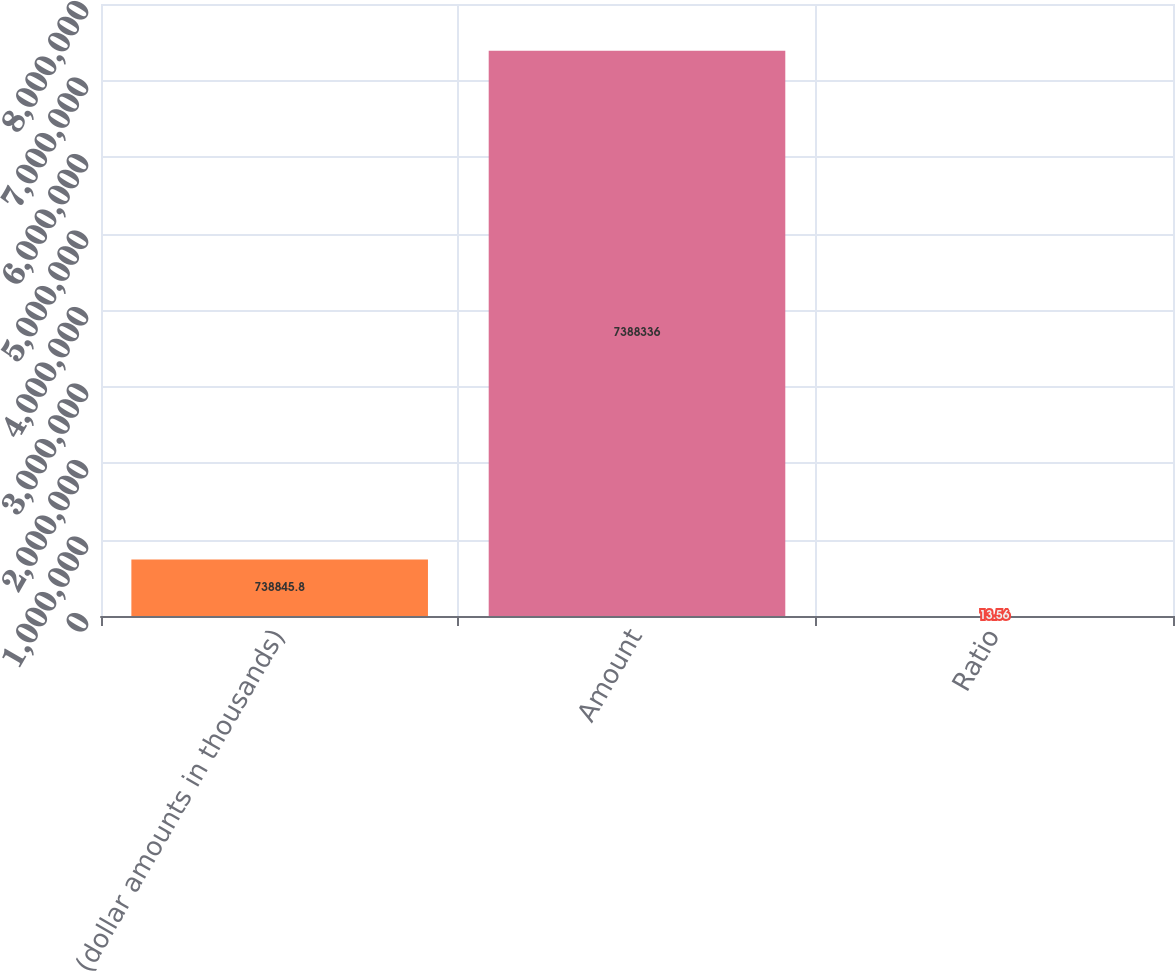Convert chart. <chart><loc_0><loc_0><loc_500><loc_500><bar_chart><fcel>(dollar amounts in thousands)<fcel>Amount<fcel>Ratio<nl><fcel>738846<fcel>7.38834e+06<fcel>13.56<nl></chart> 